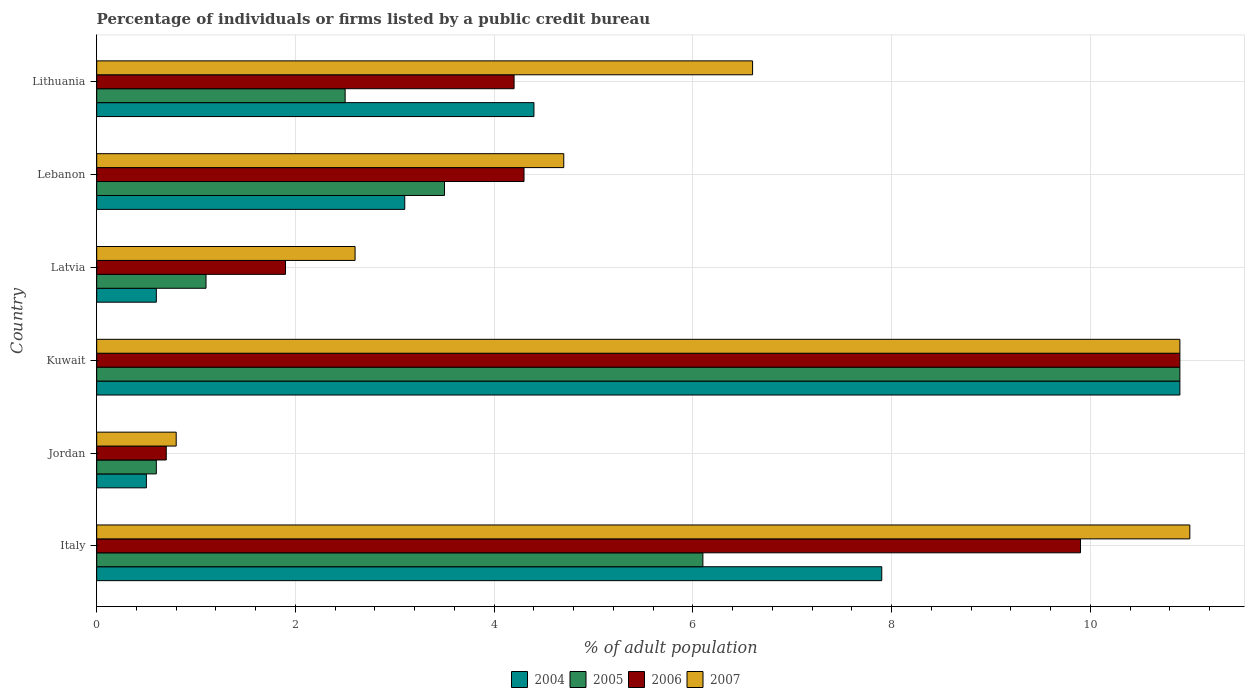How many different coloured bars are there?
Your answer should be very brief. 4. Are the number of bars per tick equal to the number of legend labels?
Provide a short and direct response. Yes. Are the number of bars on each tick of the Y-axis equal?
Offer a very short reply. Yes. How many bars are there on the 5th tick from the top?
Give a very brief answer. 4. How many bars are there on the 3rd tick from the bottom?
Provide a succinct answer. 4. What is the label of the 1st group of bars from the top?
Your response must be concise. Lithuania. Across all countries, what is the maximum percentage of population listed by a public credit bureau in 2006?
Provide a succinct answer. 10.9. Across all countries, what is the minimum percentage of population listed by a public credit bureau in 2007?
Keep it short and to the point. 0.8. In which country was the percentage of population listed by a public credit bureau in 2005 maximum?
Provide a succinct answer. Kuwait. In which country was the percentage of population listed by a public credit bureau in 2005 minimum?
Provide a short and direct response. Jordan. What is the total percentage of population listed by a public credit bureau in 2004 in the graph?
Provide a short and direct response. 27.4. What is the difference between the percentage of population listed by a public credit bureau in 2004 in Italy and that in Latvia?
Give a very brief answer. 7.3. What is the difference between the percentage of population listed by a public credit bureau in 2005 in Kuwait and the percentage of population listed by a public credit bureau in 2007 in Lithuania?
Your answer should be very brief. 4.3. What is the average percentage of population listed by a public credit bureau in 2007 per country?
Keep it short and to the point. 6.1. What is the difference between the percentage of population listed by a public credit bureau in 2005 and percentage of population listed by a public credit bureau in 2007 in Latvia?
Keep it short and to the point. -1.5. What is the ratio of the percentage of population listed by a public credit bureau in 2004 in Italy to that in Kuwait?
Provide a succinct answer. 0.72. Is the percentage of population listed by a public credit bureau in 2007 in Jordan less than that in Latvia?
Keep it short and to the point. Yes. What is the difference between the highest and the second highest percentage of population listed by a public credit bureau in 2005?
Ensure brevity in your answer.  4.8. What is the difference between the highest and the lowest percentage of population listed by a public credit bureau in 2006?
Give a very brief answer. 10.2. In how many countries, is the percentage of population listed by a public credit bureau in 2006 greater than the average percentage of population listed by a public credit bureau in 2006 taken over all countries?
Offer a very short reply. 2. Is it the case that in every country, the sum of the percentage of population listed by a public credit bureau in 2006 and percentage of population listed by a public credit bureau in 2007 is greater than the sum of percentage of population listed by a public credit bureau in 2004 and percentage of population listed by a public credit bureau in 2005?
Give a very brief answer. No. What does the 2nd bar from the top in Jordan represents?
Your answer should be very brief. 2006. Is it the case that in every country, the sum of the percentage of population listed by a public credit bureau in 2004 and percentage of population listed by a public credit bureau in 2005 is greater than the percentage of population listed by a public credit bureau in 2007?
Your answer should be very brief. No. Are all the bars in the graph horizontal?
Make the answer very short. Yes. Are the values on the major ticks of X-axis written in scientific E-notation?
Provide a succinct answer. No. Does the graph contain grids?
Your answer should be compact. Yes. Where does the legend appear in the graph?
Make the answer very short. Bottom center. How are the legend labels stacked?
Provide a succinct answer. Horizontal. What is the title of the graph?
Make the answer very short. Percentage of individuals or firms listed by a public credit bureau. What is the label or title of the X-axis?
Ensure brevity in your answer.  % of adult population. What is the % of adult population in 2007 in Italy?
Make the answer very short. 11. What is the % of adult population of 2004 in Kuwait?
Your answer should be very brief. 10.9. What is the % of adult population of 2005 in Latvia?
Give a very brief answer. 1.1. What is the % of adult population of 2006 in Latvia?
Your answer should be compact. 1.9. What is the % of adult population in 2007 in Latvia?
Your response must be concise. 2.6. What is the % of adult population of 2004 in Lebanon?
Provide a short and direct response. 3.1. What is the % of adult population in 2005 in Lebanon?
Provide a short and direct response. 3.5. What is the % of adult population of 2007 in Lebanon?
Offer a terse response. 4.7. What is the % of adult population in 2004 in Lithuania?
Provide a short and direct response. 4.4. What is the % of adult population in 2005 in Lithuania?
Your response must be concise. 2.5. What is the % of adult population of 2006 in Lithuania?
Provide a succinct answer. 4.2. What is the % of adult population of 2007 in Lithuania?
Give a very brief answer. 6.6. Across all countries, what is the maximum % of adult population of 2004?
Offer a terse response. 10.9. Across all countries, what is the minimum % of adult population in 2004?
Keep it short and to the point. 0.5. Across all countries, what is the minimum % of adult population of 2005?
Give a very brief answer. 0.6. Across all countries, what is the minimum % of adult population in 2006?
Offer a very short reply. 0.7. Across all countries, what is the minimum % of adult population in 2007?
Make the answer very short. 0.8. What is the total % of adult population in 2004 in the graph?
Provide a succinct answer. 27.4. What is the total % of adult population in 2005 in the graph?
Make the answer very short. 24.7. What is the total % of adult population of 2006 in the graph?
Offer a very short reply. 31.9. What is the total % of adult population of 2007 in the graph?
Your answer should be very brief. 36.6. What is the difference between the % of adult population of 2004 in Italy and that in Kuwait?
Keep it short and to the point. -3. What is the difference between the % of adult population in 2005 in Italy and that in Kuwait?
Provide a short and direct response. -4.8. What is the difference between the % of adult population in 2006 in Italy and that in Kuwait?
Your response must be concise. -1. What is the difference between the % of adult population in 2007 in Italy and that in Kuwait?
Your answer should be very brief. 0.1. What is the difference between the % of adult population in 2006 in Italy and that in Latvia?
Your answer should be very brief. 8. What is the difference between the % of adult population in 2007 in Italy and that in Latvia?
Your answer should be very brief. 8.4. What is the difference between the % of adult population of 2006 in Italy and that in Lebanon?
Offer a very short reply. 5.6. What is the difference between the % of adult population of 2007 in Italy and that in Lebanon?
Ensure brevity in your answer.  6.3. What is the difference between the % of adult population of 2004 in Italy and that in Lithuania?
Make the answer very short. 3.5. What is the difference between the % of adult population of 2005 in Jordan and that in Kuwait?
Provide a succinct answer. -10.3. What is the difference between the % of adult population of 2006 in Jordan and that in Kuwait?
Ensure brevity in your answer.  -10.2. What is the difference between the % of adult population of 2006 in Jordan and that in Latvia?
Provide a short and direct response. -1.2. What is the difference between the % of adult population of 2004 in Jordan and that in Lebanon?
Keep it short and to the point. -2.6. What is the difference between the % of adult population of 2006 in Jordan and that in Lebanon?
Your answer should be very brief. -3.6. What is the difference between the % of adult population in 2007 in Jordan and that in Lithuania?
Your answer should be very brief. -5.8. What is the difference between the % of adult population of 2005 in Kuwait and that in Latvia?
Offer a terse response. 9.8. What is the difference between the % of adult population in 2005 in Kuwait and that in Lebanon?
Keep it short and to the point. 7.4. What is the difference between the % of adult population of 2006 in Kuwait and that in Lebanon?
Ensure brevity in your answer.  6.6. What is the difference between the % of adult population in 2004 in Kuwait and that in Lithuania?
Provide a short and direct response. 6.5. What is the difference between the % of adult population in 2006 in Kuwait and that in Lithuania?
Offer a terse response. 6.7. What is the difference between the % of adult population in 2007 in Kuwait and that in Lithuania?
Ensure brevity in your answer.  4.3. What is the difference between the % of adult population in 2005 in Latvia and that in Lebanon?
Offer a very short reply. -2.4. What is the difference between the % of adult population of 2005 in Latvia and that in Lithuania?
Offer a very short reply. -1.4. What is the difference between the % of adult population in 2007 in Latvia and that in Lithuania?
Your response must be concise. -4. What is the difference between the % of adult population of 2006 in Lebanon and that in Lithuania?
Give a very brief answer. 0.1. What is the difference between the % of adult population in 2004 in Italy and the % of adult population in 2005 in Jordan?
Your answer should be very brief. 7.3. What is the difference between the % of adult population in 2004 in Italy and the % of adult population in 2006 in Jordan?
Provide a short and direct response. 7.2. What is the difference between the % of adult population in 2004 in Italy and the % of adult population in 2007 in Jordan?
Your answer should be very brief. 7.1. What is the difference between the % of adult population of 2005 in Italy and the % of adult population of 2006 in Jordan?
Give a very brief answer. 5.4. What is the difference between the % of adult population of 2005 in Italy and the % of adult population of 2007 in Jordan?
Make the answer very short. 5.3. What is the difference between the % of adult population in 2006 in Italy and the % of adult population in 2007 in Jordan?
Make the answer very short. 9.1. What is the difference between the % of adult population of 2004 in Italy and the % of adult population of 2006 in Kuwait?
Offer a very short reply. -3. What is the difference between the % of adult population of 2004 in Italy and the % of adult population of 2007 in Kuwait?
Provide a succinct answer. -3. What is the difference between the % of adult population in 2005 in Italy and the % of adult population in 2006 in Kuwait?
Your response must be concise. -4.8. What is the difference between the % of adult population of 2005 in Italy and the % of adult population of 2007 in Kuwait?
Your answer should be compact. -4.8. What is the difference between the % of adult population in 2004 in Italy and the % of adult population in 2005 in Latvia?
Provide a short and direct response. 6.8. What is the difference between the % of adult population in 2004 in Italy and the % of adult population in 2006 in Latvia?
Provide a succinct answer. 6. What is the difference between the % of adult population of 2004 in Italy and the % of adult population of 2007 in Latvia?
Provide a short and direct response. 5.3. What is the difference between the % of adult population of 2005 in Italy and the % of adult population of 2006 in Latvia?
Make the answer very short. 4.2. What is the difference between the % of adult population of 2006 in Italy and the % of adult population of 2007 in Latvia?
Keep it short and to the point. 7.3. What is the difference between the % of adult population of 2004 in Italy and the % of adult population of 2006 in Lebanon?
Provide a short and direct response. 3.6. What is the difference between the % of adult population in 2004 in Italy and the % of adult population in 2005 in Lithuania?
Provide a succinct answer. 5.4. What is the difference between the % of adult population of 2004 in Italy and the % of adult population of 2006 in Lithuania?
Ensure brevity in your answer.  3.7. What is the difference between the % of adult population in 2004 in Italy and the % of adult population in 2007 in Lithuania?
Provide a short and direct response. 1.3. What is the difference between the % of adult population of 2006 in Italy and the % of adult population of 2007 in Lithuania?
Offer a terse response. 3.3. What is the difference between the % of adult population of 2004 in Jordan and the % of adult population of 2006 in Kuwait?
Ensure brevity in your answer.  -10.4. What is the difference between the % of adult population in 2005 in Jordan and the % of adult population in 2006 in Kuwait?
Your answer should be very brief. -10.3. What is the difference between the % of adult population of 2005 in Jordan and the % of adult population of 2007 in Kuwait?
Keep it short and to the point. -10.3. What is the difference between the % of adult population of 2004 in Jordan and the % of adult population of 2007 in Latvia?
Your answer should be very brief. -2.1. What is the difference between the % of adult population in 2005 in Jordan and the % of adult population in 2006 in Latvia?
Offer a very short reply. -1.3. What is the difference between the % of adult population in 2005 in Jordan and the % of adult population in 2007 in Latvia?
Ensure brevity in your answer.  -2. What is the difference between the % of adult population in 2006 in Jordan and the % of adult population in 2007 in Latvia?
Your answer should be compact. -1.9. What is the difference between the % of adult population in 2005 in Jordan and the % of adult population in 2006 in Lebanon?
Your answer should be very brief. -3.7. What is the difference between the % of adult population of 2005 in Jordan and the % of adult population of 2007 in Lebanon?
Your answer should be very brief. -4.1. What is the difference between the % of adult population in 2006 in Jordan and the % of adult population in 2007 in Lebanon?
Your response must be concise. -4. What is the difference between the % of adult population in 2004 in Jordan and the % of adult population in 2007 in Lithuania?
Your response must be concise. -6.1. What is the difference between the % of adult population in 2004 in Kuwait and the % of adult population in 2005 in Latvia?
Ensure brevity in your answer.  9.8. What is the difference between the % of adult population in 2004 in Kuwait and the % of adult population in 2006 in Latvia?
Make the answer very short. 9. What is the difference between the % of adult population in 2005 in Kuwait and the % of adult population in 2006 in Latvia?
Offer a terse response. 9. What is the difference between the % of adult population of 2005 in Kuwait and the % of adult population of 2007 in Latvia?
Provide a succinct answer. 8.3. What is the difference between the % of adult population in 2006 in Kuwait and the % of adult population in 2007 in Latvia?
Provide a short and direct response. 8.3. What is the difference between the % of adult population of 2004 in Kuwait and the % of adult population of 2005 in Lebanon?
Offer a very short reply. 7.4. What is the difference between the % of adult population in 2004 in Kuwait and the % of adult population in 2007 in Lebanon?
Your answer should be compact. 6.2. What is the difference between the % of adult population in 2006 in Kuwait and the % of adult population in 2007 in Lebanon?
Make the answer very short. 6.2. What is the difference between the % of adult population of 2005 in Kuwait and the % of adult population of 2006 in Lithuania?
Offer a terse response. 6.7. What is the difference between the % of adult population in 2005 in Kuwait and the % of adult population in 2007 in Lithuania?
Your answer should be very brief. 4.3. What is the difference between the % of adult population of 2006 in Kuwait and the % of adult population of 2007 in Lithuania?
Make the answer very short. 4.3. What is the difference between the % of adult population in 2004 in Latvia and the % of adult population in 2005 in Lebanon?
Provide a short and direct response. -2.9. What is the difference between the % of adult population of 2004 in Latvia and the % of adult population of 2006 in Lebanon?
Your response must be concise. -3.7. What is the difference between the % of adult population of 2004 in Latvia and the % of adult population of 2007 in Lebanon?
Provide a succinct answer. -4.1. What is the difference between the % of adult population of 2005 in Latvia and the % of adult population of 2007 in Lebanon?
Offer a very short reply. -3.6. What is the difference between the % of adult population in 2004 in Latvia and the % of adult population in 2005 in Lithuania?
Offer a very short reply. -1.9. What is the difference between the % of adult population of 2005 in Latvia and the % of adult population of 2006 in Lithuania?
Keep it short and to the point. -3.1. What is the difference between the % of adult population of 2006 in Latvia and the % of adult population of 2007 in Lithuania?
Your answer should be very brief. -4.7. What is the difference between the % of adult population of 2004 in Lebanon and the % of adult population of 2006 in Lithuania?
Your answer should be compact. -1.1. What is the difference between the % of adult population of 2004 in Lebanon and the % of adult population of 2007 in Lithuania?
Give a very brief answer. -3.5. What is the difference between the % of adult population of 2005 in Lebanon and the % of adult population of 2006 in Lithuania?
Provide a short and direct response. -0.7. What is the difference between the % of adult population in 2005 in Lebanon and the % of adult population in 2007 in Lithuania?
Your answer should be compact. -3.1. What is the difference between the % of adult population in 2006 in Lebanon and the % of adult population in 2007 in Lithuania?
Provide a succinct answer. -2.3. What is the average % of adult population in 2004 per country?
Your answer should be compact. 4.57. What is the average % of adult population of 2005 per country?
Provide a short and direct response. 4.12. What is the average % of adult population in 2006 per country?
Give a very brief answer. 5.32. What is the difference between the % of adult population of 2004 and % of adult population of 2005 in Italy?
Provide a succinct answer. 1.8. What is the difference between the % of adult population of 2004 and % of adult population of 2006 in Italy?
Your answer should be compact. -2. What is the difference between the % of adult population in 2004 and % of adult population in 2007 in Italy?
Your answer should be compact. -3.1. What is the difference between the % of adult population of 2005 and % of adult population of 2006 in Italy?
Your response must be concise. -3.8. What is the difference between the % of adult population in 2005 and % of adult population in 2007 in Italy?
Offer a very short reply. -4.9. What is the difference between the % of adult population in 2004 and % of adult population in 2005 in Jordan?
Provide a succinct answer. -0.1. What is the difference between the % of adult population in 2004 and % of adult population in 2006 in Jordan?
Your response must be concise. -0.2. What is the difference between the % of adult population of 2004 and % of adult population of 2007 in Jordan?
Offer a very short reply. -0.3. What is the difference between the % of adult population of 2005 and % of adult population of 2007 in Jordan?
Your answer should be compact. -0.2. What is the difference between the % of adult population in 2006 and % of adult population in 2007 in Jordan?
Offer a terse response. -0.1. What is the difference between the % of adult population of 2004 and % of adult population of 2006 in Kuwait?
Give a very brief answer. 0. What is the difference between the % of adult population of 2005 and % of adult population of 2006 in Kuwait?
Offer a terse response. 0. What is the difference between the % of adult population in 2005 and % of adult population in 2007 in Kuwait?
Provide a succinct answer. 0. What is the difference between the % of adult population of 2004 and % of adult population of 2006 in Latvia?
Make the answer very short. -1.3. What is the difference between the % of adult population in 2005 and % of adult population in 2006 in Latvia?
Your response must be concise. -0.8. What is the difference between the % of adult population of 2006 and % of adult population of 2007 in Latvia?
Your answer should be very brief. -0.7. What is the difference between the % of adult population of 2004 and % of adult population of 2006 in Lebanon?
Make the answer very short. -1.2. What is the difference between the % of adult population of 2004 and % of adult population of 2007 in Lithuania?
Provide a succinct answer. -2.2. What is the difference between the % of adult population in 2005 and % of adult population in 2006 in Lithuania?
Keep it short and to the point. -1.7. What is the difference between the % of adult population in 2006 and % of adult population in 2007 in Lithuania?
Your answer should be very brief. -2.4. What is the ratio of the % of adult population of 2005 in Italy to that in Jordan?
Your answer should be compact. 10.17. What is the ratio of the % of adult population in 2006 in Italy to that in Jordan?
Your response must be concise. 14.14. What is the ratio of the % of adult population in 2007 in Italy to that in Jordan?
Give a very brief answer. 13.75. What is the ratio of the % of adult population in 2004 in Italy to that in Kuwait?
Your answer should be very brief. 0.72. What is the ratio of the % of adult population in 2005 in Italy to that in Kuwait?
Provide a succinct answer. 0.56. What is the ratio of the % of adult population in 2006 in Italy to that in Kuwait?
Make the answer very short. 0.91. What is the ratio of the % of adult population of 2007 in Italy to that in Kuwait?
Your answer should be compact. 1.01. What is the ratio of the % of adult population of 2004 in Italy to that in Latvia?
Provide a short and direct response. 13.17. What is the ratio of the % of adult population of 2005 in Italy to that in Latvia?
Your answer should be very brief. 5.55. What is the ratio of the % of adult population of 2006 in Italy to that in Latvia?
Your answer should be very brief. 5.21. What is the ratio of the % of adult population of 2007 in Italy to that in Latvia?
Provide a succinct answer. 4.23. What is the ratio of the % of adult population of 2004 in Italy to that in Lebanon?
Give a very brief answer. 2.55. What is the ratio of the % of adult population in 2005 in Italy to that in Lebanon?
Give a very brief answer. 1.74. What is the ratio of the % of adult population of 2006 in Italy to that in Lebanon?
Your answer should be very brief. 2.3. What is the ratio of the % of adult population in 2007 in Italy to that in Lebanon?
Offer a very short reply. 2.34. What is the ratio of the % of adult population in 2004 in Italy to that in Lithuania?
Offer a terse response. 1.8. What is the ratio of the % of adult population of 2005 in Italy to that in Lithuania?
Offer a very short reply. 2.44. What is the ratio of the % of adult population in 2006 in Italy to that in Lithuania?
Keep it short and to the point. 2.36. What is the ratio of the % of adult population in 2004 in Jordan to that in Kuwait?
Provide a succinct answer. 0.05. What is the ratio of the % of adult population of 2005 in Jordan to that in Kuwait?
Your answer should be very brief. 0.06. What is the ratio of the % of adult population in 2006 in Jordan to that in Kuwait?
Make the answer very short. 0.06. What is the ratio of the % of adult population of 2007 in Jordan to that in Kuwait?
Provide a succinct answer. 0.07. What is the ratio of the % of adult population of 2005 in Jordan to that in Latvia?
Give a very brief answer. 0.55. What is the ratio of the % of adult population in 2006 in Jordan to that in Latvia?
Provide a succinct answer. 0.37. What is the ratio of the % of adult population of 2007 in Jordan to that in Latvia?
Your answer should be compact. 0.31. What is the ratio of the % of adult population in 2004 in Jordan to that in Lebanon?
Your response must be concise. 0.16. What is the ratio of the % of adult population of 2005 in Jordan to that in Lebanon?
Your answer should be very brief. 0.17. What is the ratio of the % of adult population of 2006 in Jordan to that in Lebanon?
Your response must be concise. 0.16. What is the ratio of the % of adult population in 2007 in Jordan to that in Lebanon?
Provide a short and direct response. 0.17. What is the ratio of the % of adult population in 2004 in Jordan to that in Lithuania?
Offer a terse response. 0.11. What is the ratio of the % of adult population in 2005 in Jordan to that in Lithuania?
Keep it short and to the point. 0.24. What is the ratio of the % of adult population in 2007 in Jordan to that in Lithuania?
Ensure brevity in your answer.  0.12. What is the ratio of the % of adult population in 2004 in Kuwait to that in Latvia?
Offer a very short reply. 18.17. What is the ratio of the % of adult population of 2005 in Kuwait to that in Latvia?
Ensure brevity in your answer.  9.91. What is the ratio of the % of adult population of 2006 in Kuwait to that in Latvia?
Make the answer very short. 5.74. What is the ratio of the % of adult population in 2007 in Kuwait to that in Latvia?
Your answer should be very brief. 4.19. What is the ratio of the % of adult population in 2004 in Kuwait to that in Lebanon?
Ensure brevity in your answer.  3.52. What is the ratio of the % of adult population in 2005 in Kuwait to that in Lebanon?
Ensure brevity in your answer.  3.11. What is the ratio of the % of adult population of 2006 in Kuwait to that in Lebanon?
Ensure brevity in your answer.  2.53. What is the ratio of the % of adult population of 2007 in Kuwait to that in Lebanon?
Keep it short and to the point. 2.32. What is the ratio of the % of adult population of 2004 in Kuwait to that in Lithuania?
Make the answer very short. 2.48. What is the ratio of the % of adult population in 2005 in Kuwait to that in Lithuania?
Make the answer very short. 4.36. What is the ratio of the % of adult population in 2006 in Kuwait to that in Lithuania?
Make the answer very short. 2.6. What is the ratio of the % of adult population of 2007 in Kuwait to that in Lithuania?
Ensure brevity in your answer.  1.65. What is the ratio of the % of adult population of 2004 in Latvia to that in Lebanon?
Provide a short and direct response. 0.19. What is the ratio of the % of adult population of 2005 in Latvia to that in Lebanon?
Give a very brief answer. 0.31. What is the ratio of the % of adult population in 2006 in Latvia to that in Lebanon?
Make the answer very short. 0.44. What is the ratio of the % of adult population in 2007 in Latvia to that in Lebanon?
Keep it short and to the point. 0.55. What is the ratio of the % of adult population of 2004 in Latvia to that in Lithuania?
Offer a very short reply. 0.14. What is the ratio of the % of adult population in 2005 in Latvia to that in Lithuania?
Offer a very short reply. 0.44. What is the ratio of the % of adult population of 2006 in Latvia to that in Lithuania?
Your answer should be very brief. 0.45. What is the ratio of the % of adult population in 2007 in Latvia to that in Lithuania?
Your answer should be very brief. 0.39. What is the ratio of the % of adult population of 2004 in Lebanon to that in Lithuania?
Keep it short and to the point. 0.7. What is the ratio of the % of adult population of 2006 in Lebanon to that in Lithuania?
Provide a short and direct response. 1.02. What is the ratio of the % of adult population of 2007 in Lebanon to that in Lithuania?
Make the answer very short. 0.71. What is the difference between the highest and the second highest % of adult population in 2004?
Keep it short and to the point. 3. What is the difference between the highest and the second highest % of adult population of 2006?
Your response must be concise. 1. What is the difference between the highest and the second highest % of adult population of 2007?
Keep it short and to the point. 0.1. What is the difference between the highest and the lowest % of adult population in 2004?
Give a very brief answer. 10.4. What is the difference between the highest and the lowest % of adult population of 2005?
Your answer should be very brief. 10.3. What is the difference between the highest and the lowest % of adult population of 2006?
Provide a succinct answer. 10.2. 